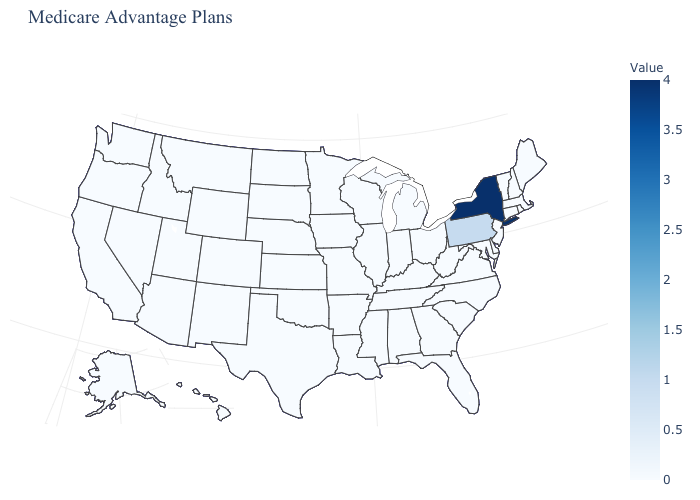Which states have the highest value in the USA?
Write a very short answer. New York. Which states have the highest value in the USA?
Give a very brief answer. New York. Among the states that border Ohio , which have the highest value?
Answer briefly. Pennsylvania. Does Delaware have the lowest value in the USA?
Concise answer only. Yes. Which states have the lowest value in the USA?
Quick response, please. Alaska, Alabama, Arkansas, Arizona, California, Colorado, Connecticut, Delaware, Florida, Georgia, Hawaii, Iowa, Idaho, Illinois, Indiana, Kansas, Kentucky, Louisiana, Massachusetts, Maryland, Maine, Michigan, Minnesota, Missouri, Mississippi, Montana, North Carolina, North Dakota, Nebraska, New Hampshire, New Jersey, New Mexico, Nevada, Ohio, Oklahoma, Oregon, Rhode Island, South Carolina, South Dakota, Tennessee, Texas, Utah, Virginia, Vermont, Washington, Wisconsin, West Virginia, Wyoming. Among the states that border Alabama , which have the highest value?
Write a very short answer. Florida, Georgia, Mississippi, Tennessee. 